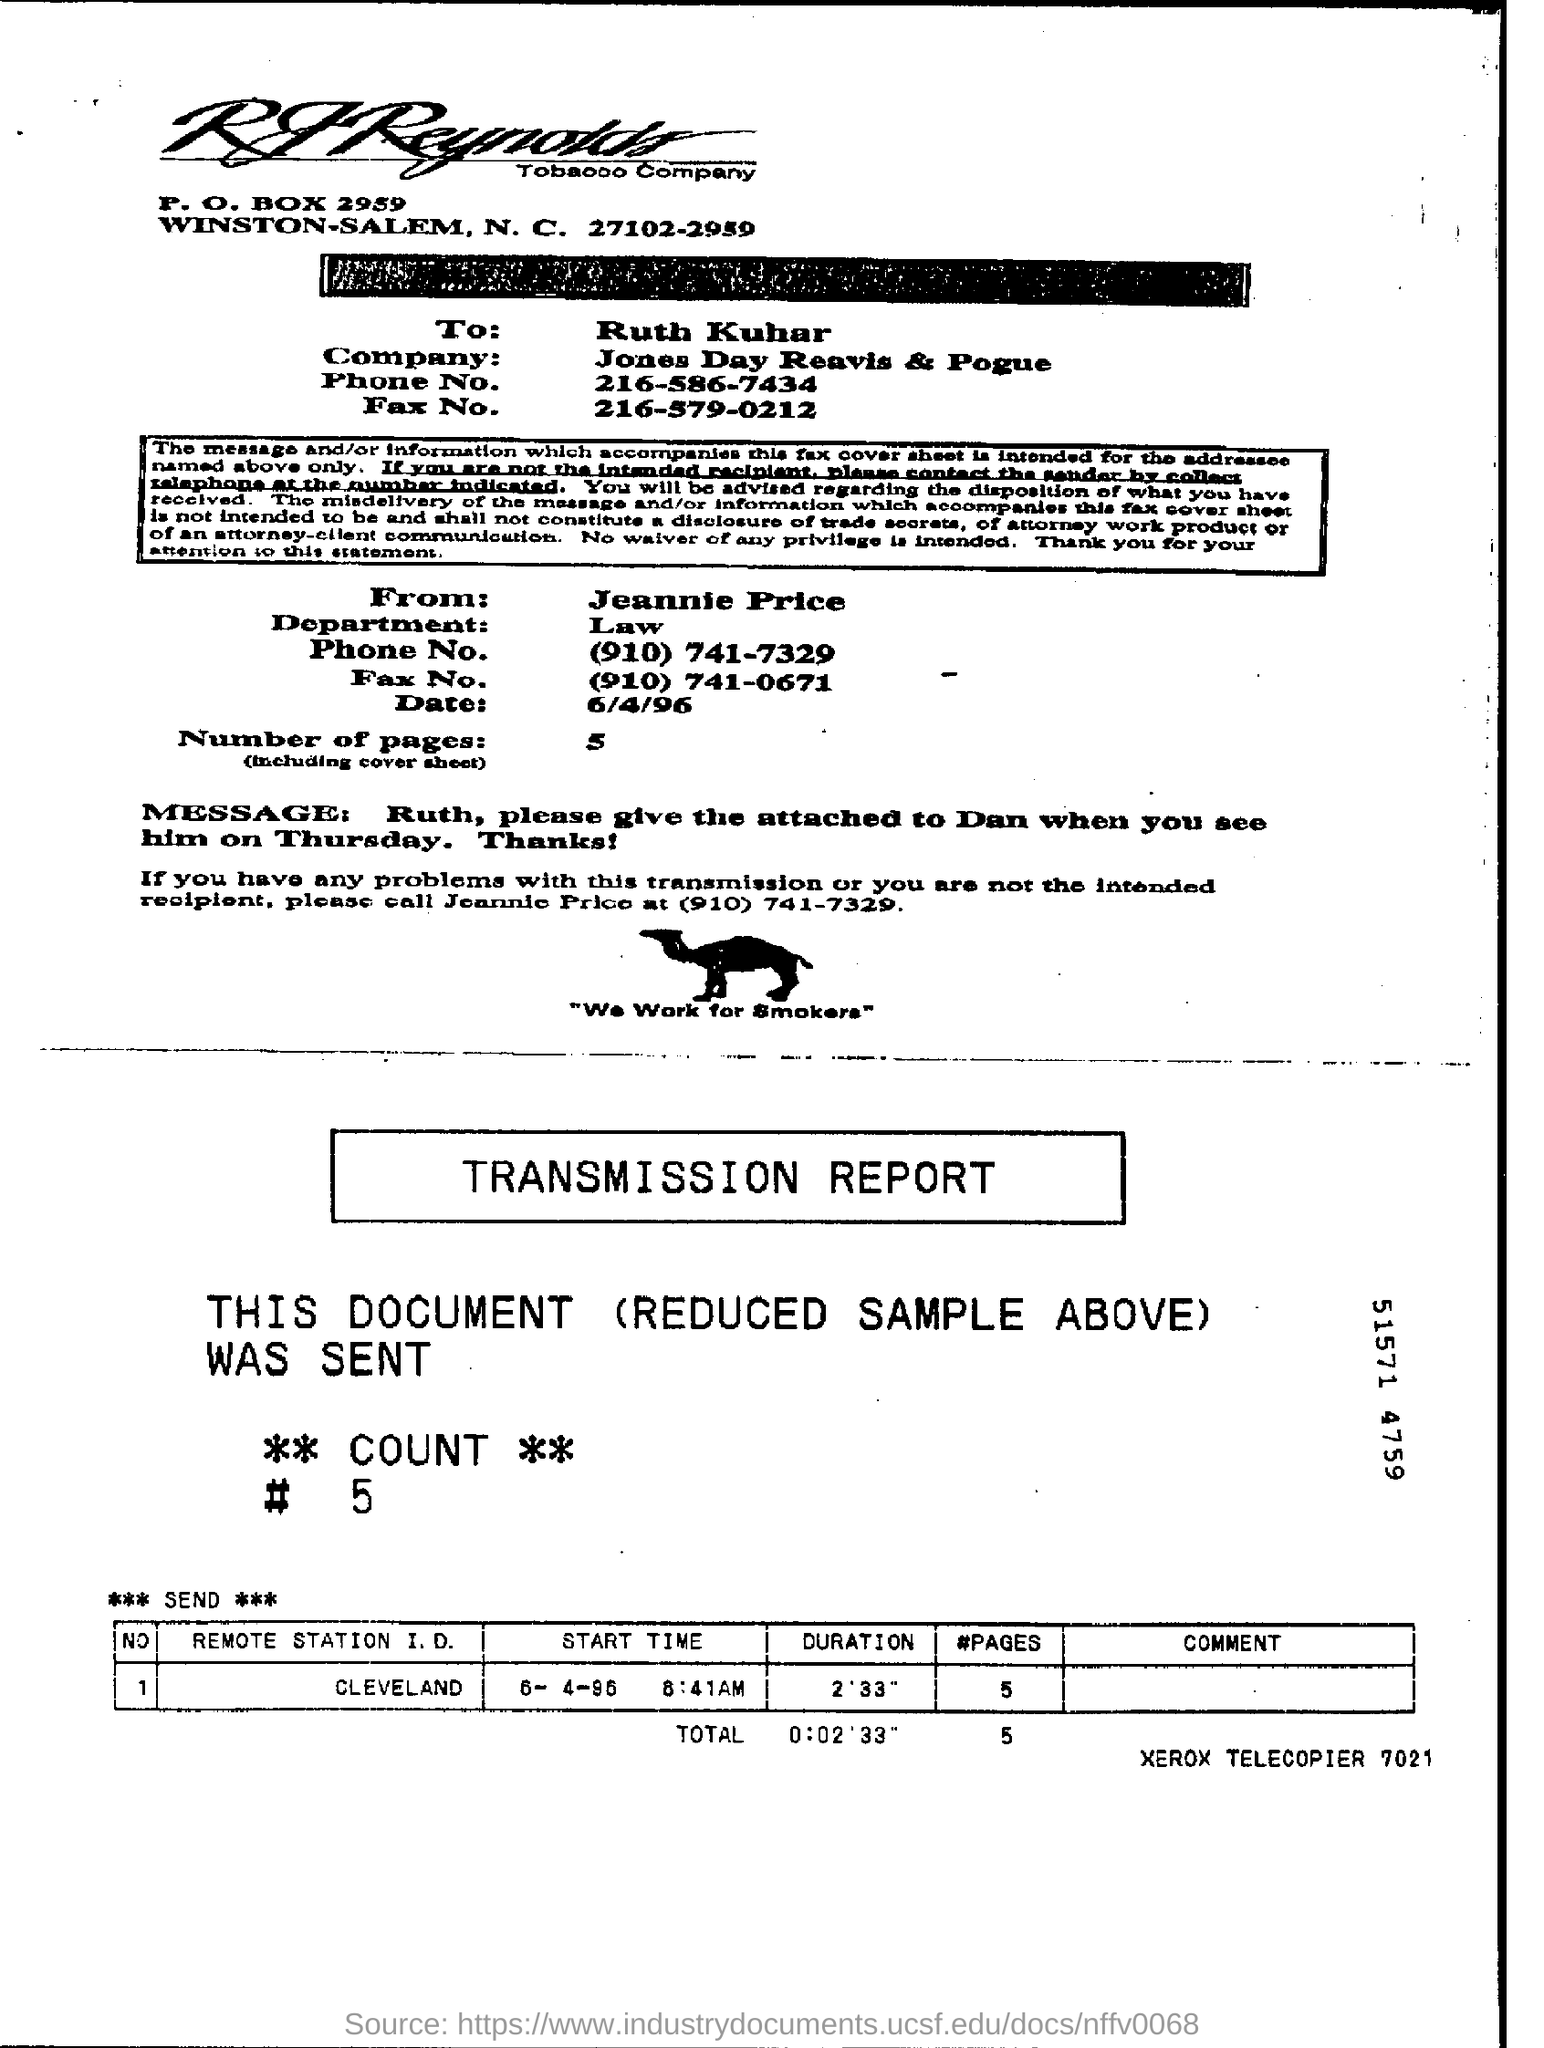Identify some key points in this picture. Jeannie Price belongs to the Law department. There are five pages mentioned in total. The remote station identified as Cleveland 